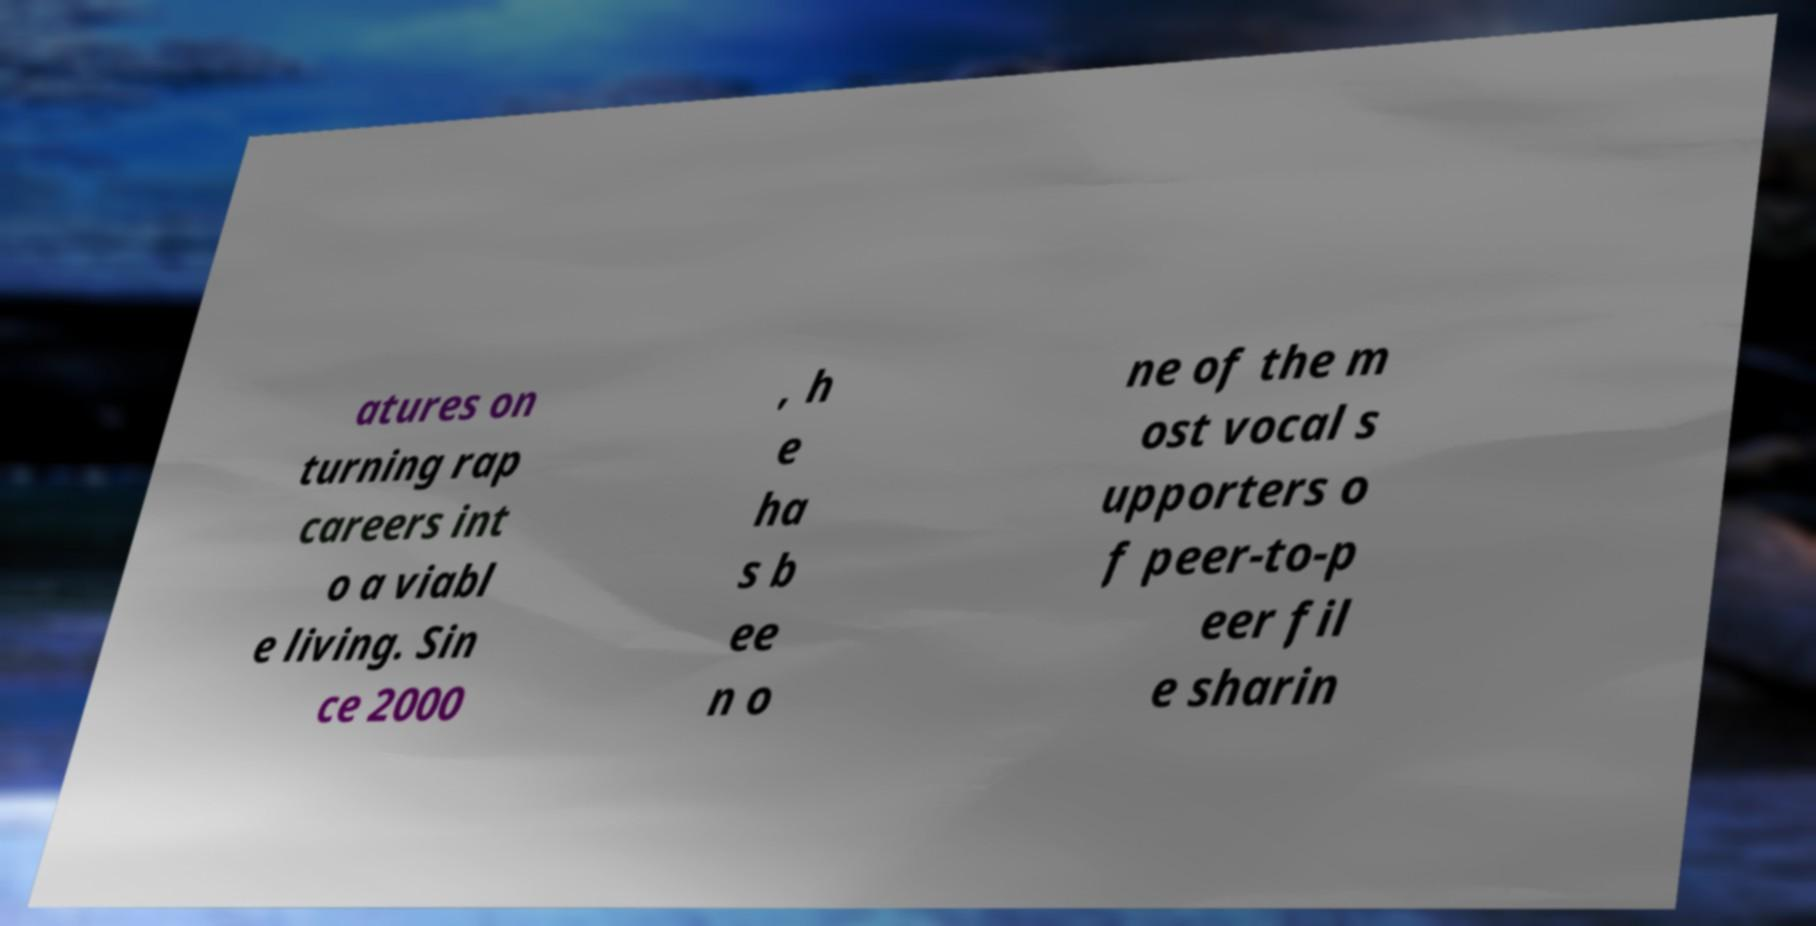Can you accurately transcribe the text from the provided image for me? atures on turning rap careers int o a viabl e living. Sin ce 2000 , h e ha s b ee n o ne of the m ost vocal s upporters o f peer-to-p eer fil e sharin 